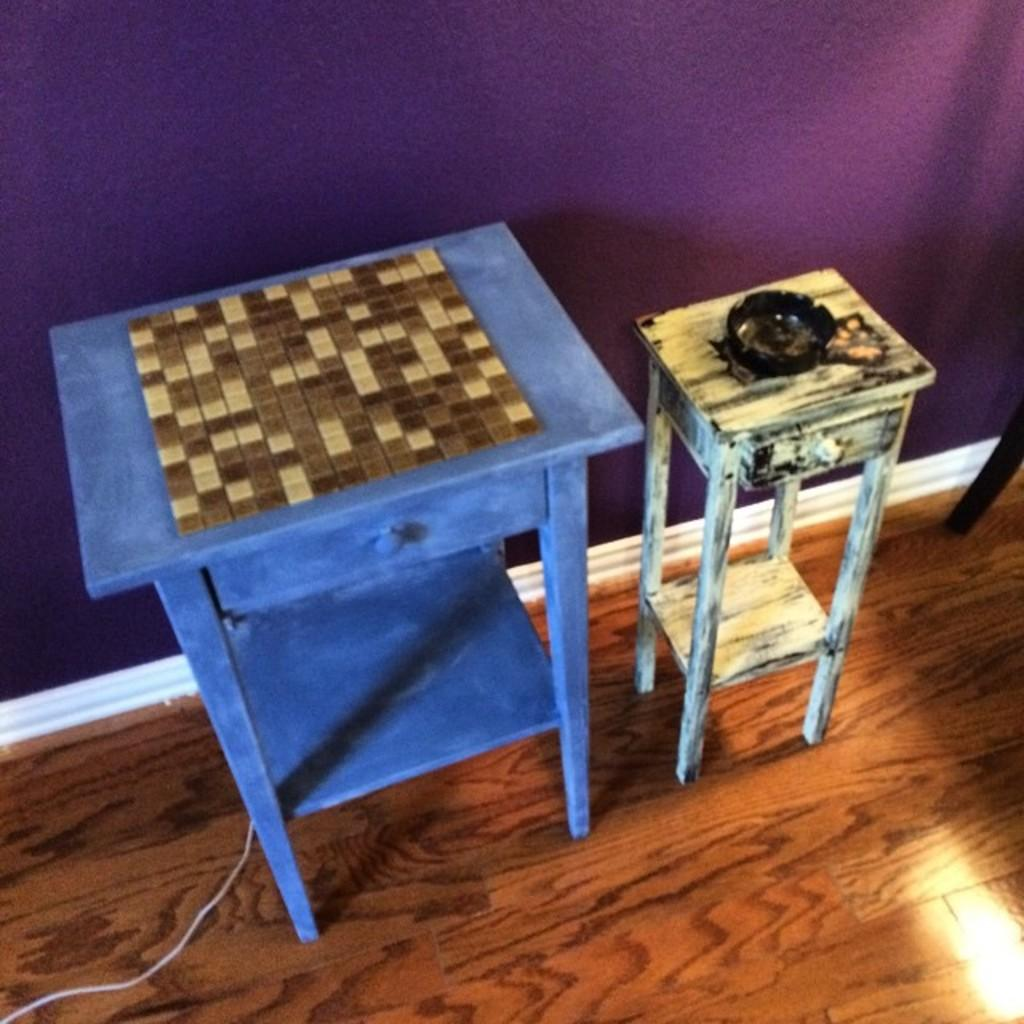What type of furniture is present in the image? There is a table and a stool in the image. What is the floor made of in the image? The floor is made of wood. What is the background of the image composed of? There is a wall in the image. Is there any electrical component visible in the image? Yes, there is a wire in the image. Can you see a baseball game happening in the image? No, there is no baseball game or any reference to sports in the image. Is there a picture of a seashore visible in the image? No, there is no picture or any reference to a seashore in the image. 